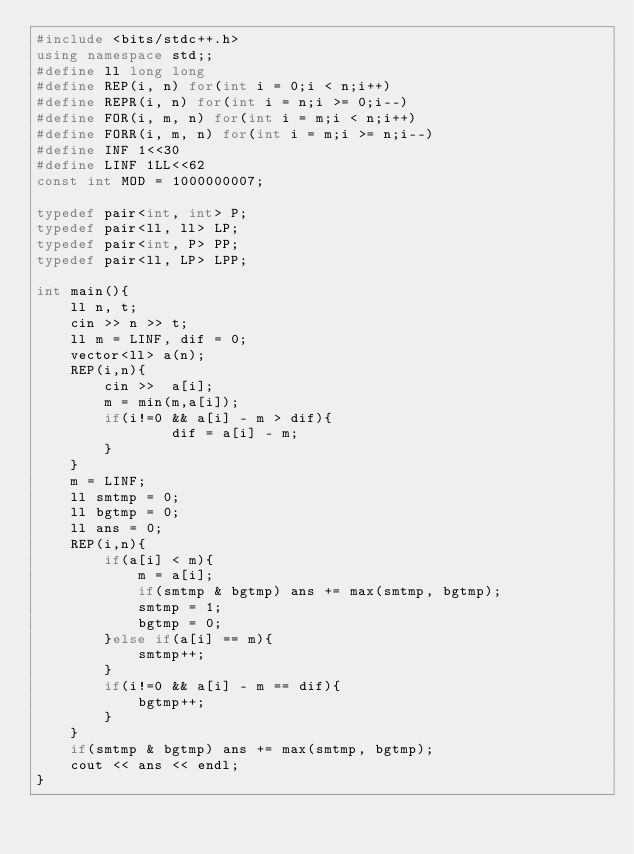Convert code to text. <code><loc_0><loc_0><loc_500><loc_500><_C++_>#include <bits/stdc++.h>
using namespace std;;
#define ll long long
#define REP(i, n) for(int i = 0;i < n;i++)
#define REPR(i, n) for(int i = n;i >= 0;i--)
#define FOR(i, m, n) for(int i = m;i < n;i++)
#define FORR(i, m, n) for(int i = m;i >= n;i--)
#define INF 1<<30
#define LINF 1LL<<62
const int MOD = 1000000007;
 
typedef pair<int, int> P;
typedef pair<ll, ll> LP;
typedef pair<int, P> PP;
typedef pair<ll, LP> LPP;

int main(){
    ll n, t;
    cin >> n >> t;
    ll m = LINF, dif = 0;
    vector<ll> a(n);
    REP(i,n){
        cin >>  a[i];
        m = min(m,a[i]);
        if(i!=0 && a[i] - m > dif){
                dif = a[i] - m;
        }
    }
    m = LINF;
    ll smtmp = 0;
    ll bgtmp = 0;
    ll ans = 0;
    REP(i,n){
        if(a[i] < m){
            m = a[i];
            if(smtmp & bgtmp) ans += max(smtmp, bgtmp);
            smtmp = 1;
            bgtmp = 0;
        }else if(a[i] == m){
            smtmp++;
        }
        if(i!=0 && a[i] - m == dif){
            bgtmp++;
        }
    }
    if(smtmp & bgtmp) ans += max(smtmp, bgtmp);
    cout << ans << endl;
}</code> 